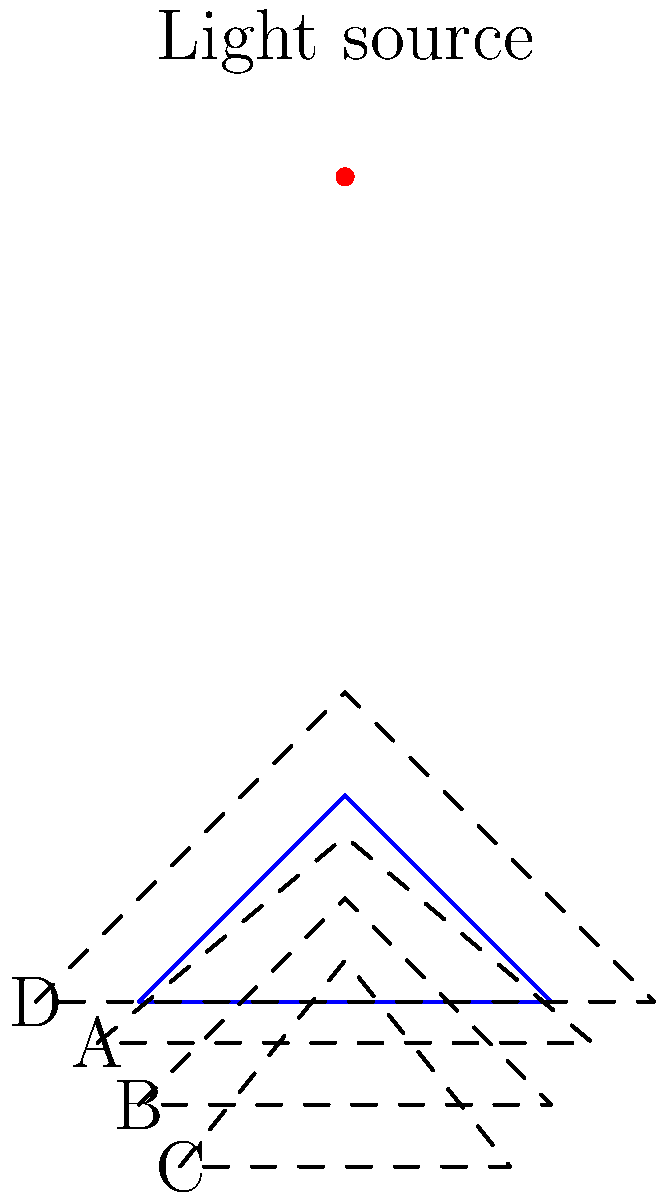An alien spacecraft with a triangular shape is hovering above a planet's surface. A single light source is positioned directly above the spacecraft. Which of the shadows (A, B, C, or D) accurately represents the spacecraft's shadow on the planet's surface? To determine the correct shadow, we need to consider the principles of light projection and shadow formation:

1. The light source is directly above the spacecraft, which means the shadow will be directly below it.
2. The shadow's shape will be similar to the spacecraft's shape but may be elongated or compressed depending on the angle of the light.
3. Since the light is directly above, the shadow will maintain the same proportions as the spacecraft.

Analyzing each option:

A: This shadow is wider than the spacecraft and slightly elongated. It doesn't maintain the correct proportions.
B: This shadow maintains the same shape and proportions as the spacecraft. It's directly below the spacecraft, which is consistent with the light source's position.
C: This shadow is narrower and more compressed than the spacecraft. It doesn't maintain the correct proportions.
D: This shadow is much larger and more elongated than the spacecraft. It doesn't maintain the correct proportions.

Therefore, option B is the only shadow that accurately represents the spacecraft's shadow given the light source's position.
Answer: B 